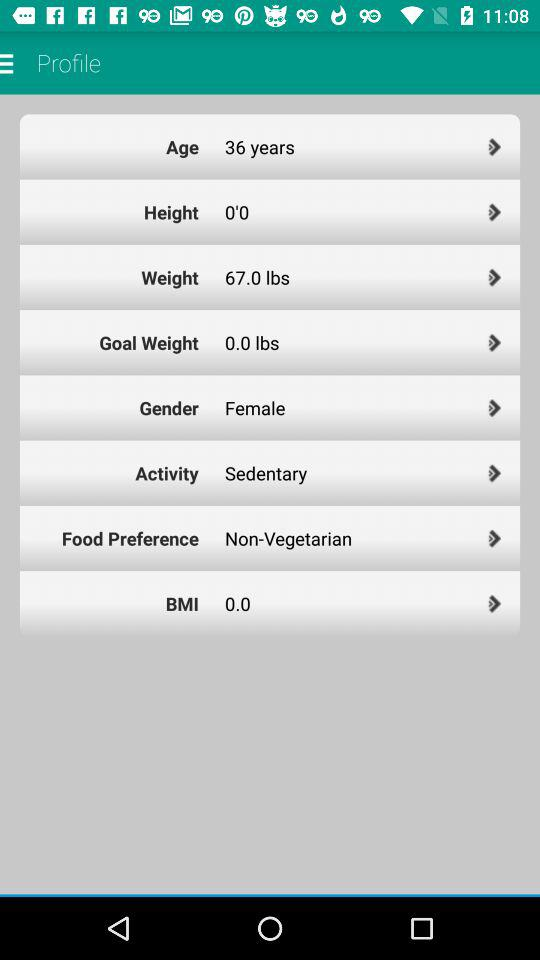Which option is selected in the gender setting? The selected option is "Female". 